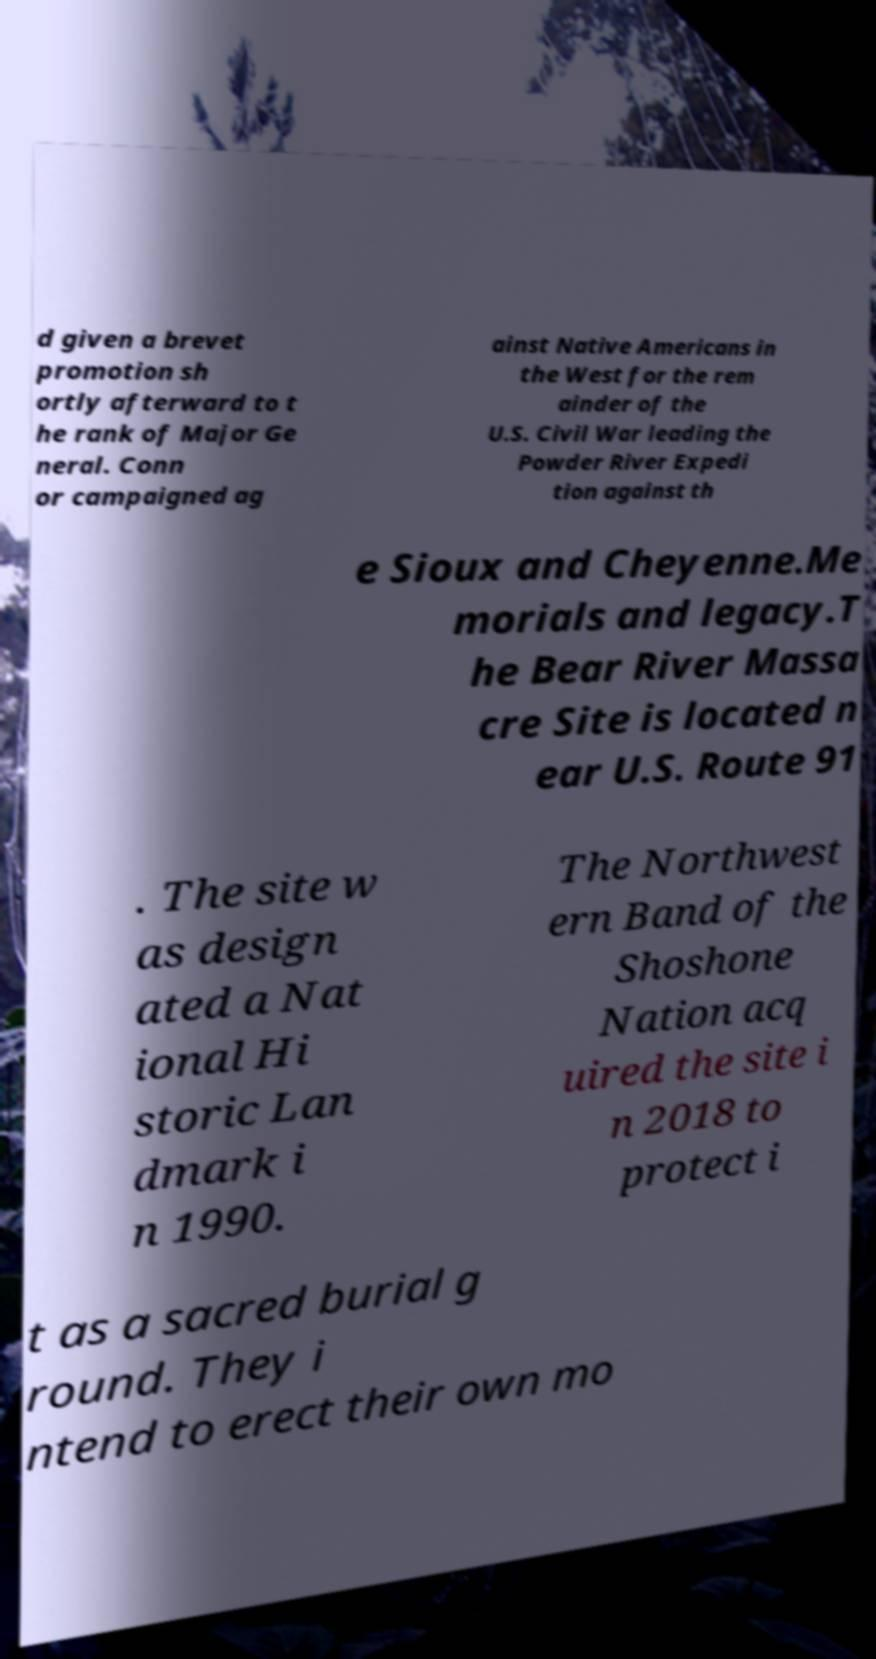I need the written content from this picture converted into text. Can you do that? d given a brevet promotion sh ortly afterward to t he rank of Major Ge neral. Conn or campaigned ag ainst Native Americans in the West for the rem ainder of the U.S. Civil War leading the Powder River Expedi tion against th e Sioux and Cheyenne.Me morials and legacy.T he Bear River Massa cre Site is located n ear U.S. Route 91 . The site w as design ated a Nat ional Hi storic Lan dmark i n 1990. The Northwest ern Band of the Shoshone Nation acq uired the site i n 2018 to protect i t as a sacred burial g round. They i ntend to erect their own mo 